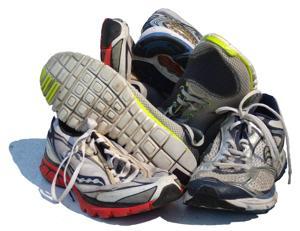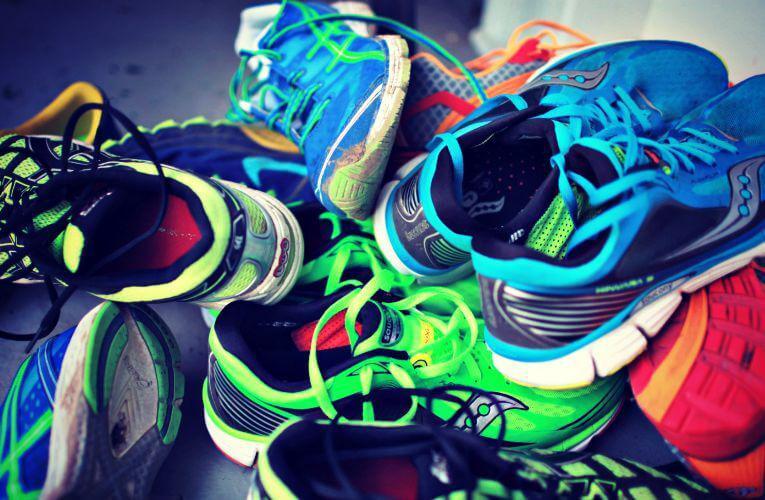The first image is the image on the left, the second image is the image on the right. Given the left and right images, does the statement "In one image only the tops and sides of the shoes are visible." hold true? Answer yes or no. No. The first image is the image on the left, the second image is the image on the right. Considering the images on both sides, is "An image shows no more than a dozen sneakers arranged in a pile with at least one sole visible." valid? Answer yes or no. Yes. The first image is the image on the left, the second image is the image on the right. Assess this claim about the two images: "The shoes in one of the pictures are not piled up on each other.". Correct or not? Answer yes or no. No. The first image is the image on the left, the second image is the image on the right. For the images displayed, is the sentence "At least one of the images prominently displays one or more Nike brand shoe with the brand's signature """"swoosh"""" logo on the side." factually correct? Answer yes or no. No. 